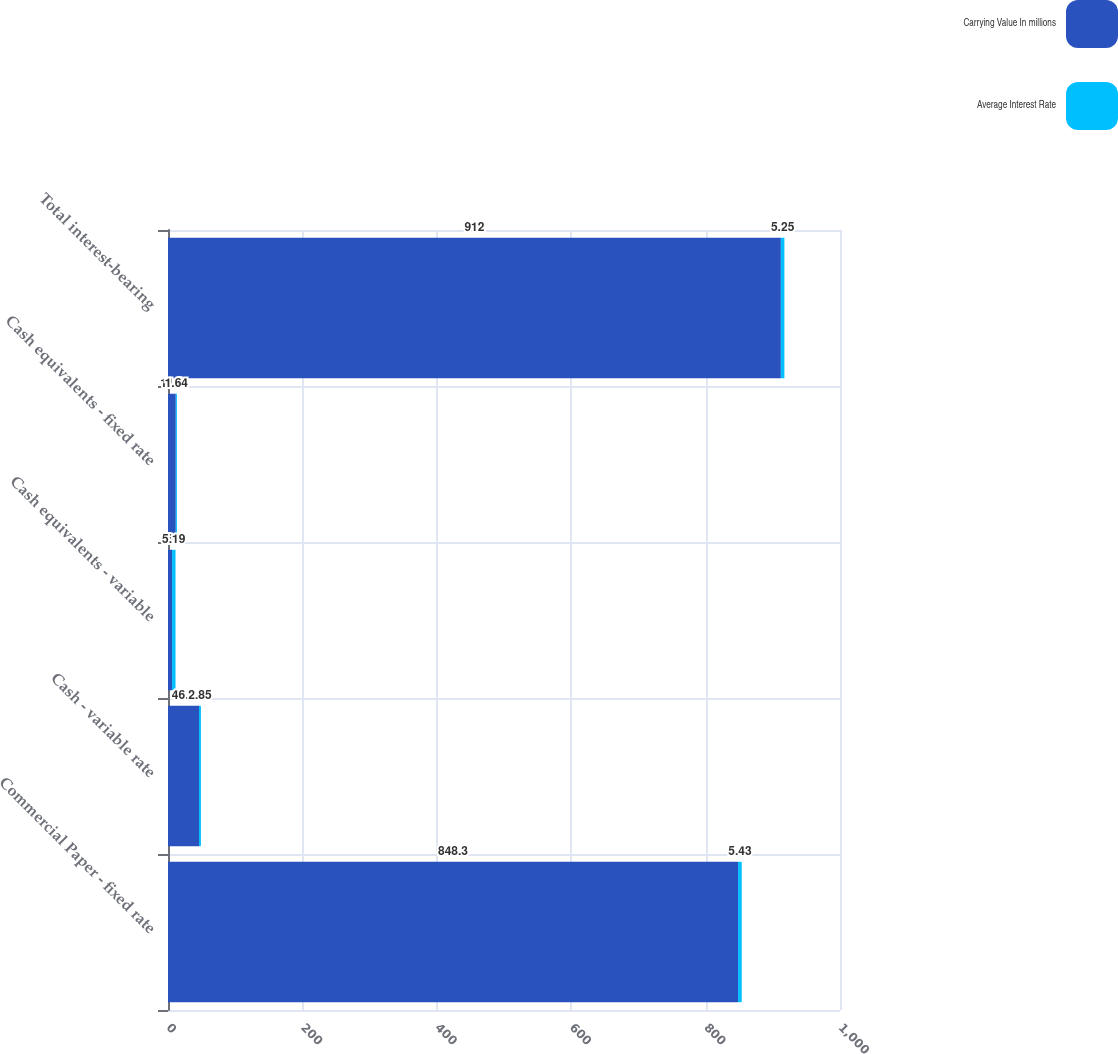<chart> <loc_0><loc_0><loc_500><loc_500><stacked_bar_chart><ecel><fcel>Commercial Paper - fixed rate<fcel>Cash - variable rate<fcel>Cash equivalents - variable<fcel>Cash equivalents - fixed rate<fcel>Total interest-bearing<nl><fcel>Carrying Value In millions<fcel>848.3<fcel>46.1<fcel>6<fcel>11.6<fcel>912<nl><fcel>Average Interest Rate<fcel>5.43<fcel>2.85<fcel>5.19<fcel>1.64<fcel>5.25<nl></chart> 